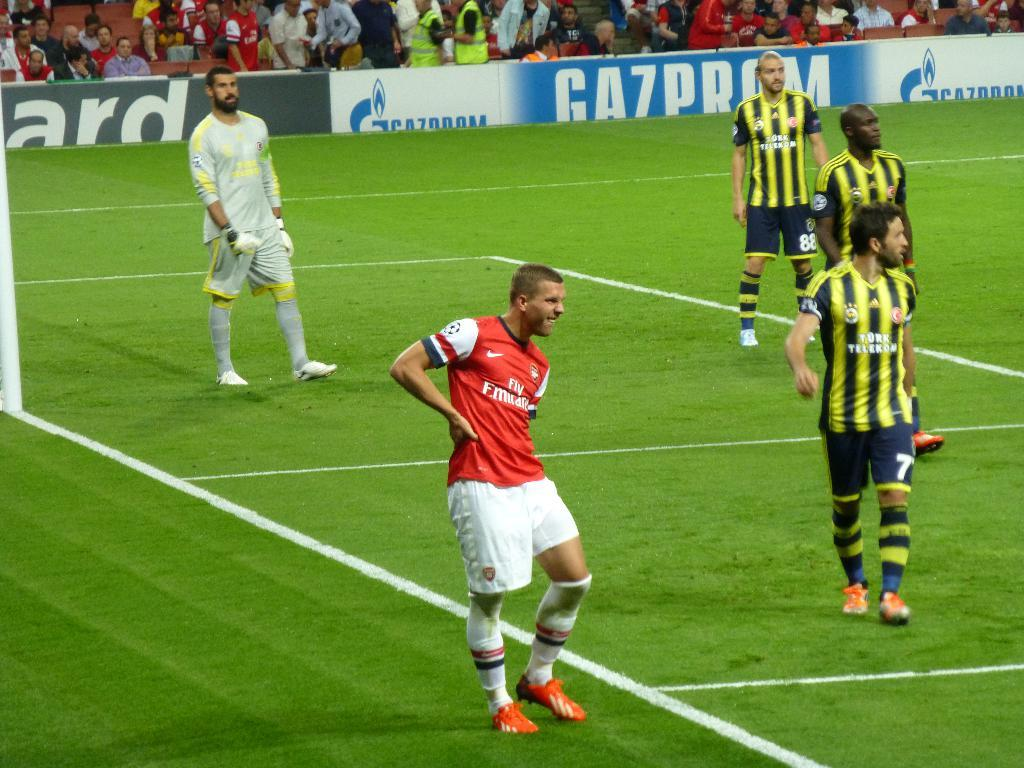<image>
Share a concise interpretation of the image provided. 5 soccer players with one man wearing the number 7 on his shorts. 